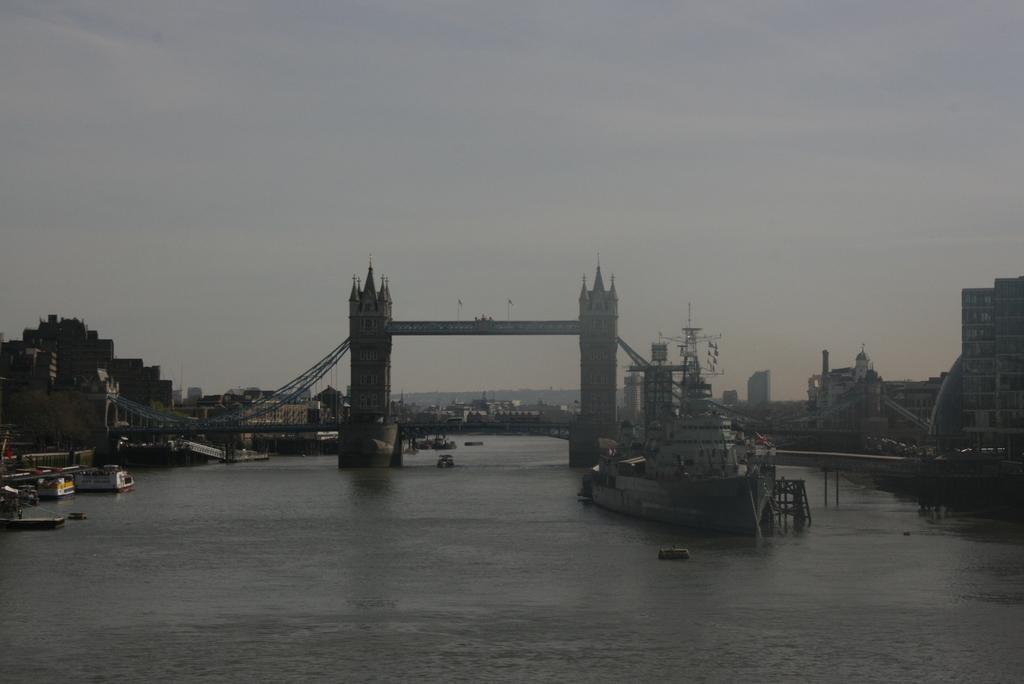Please provide a concise description of this image. In the picture we can see water with some boats, ship and behind it, we can see London bridge and behind it we can see some buildings and sky. 